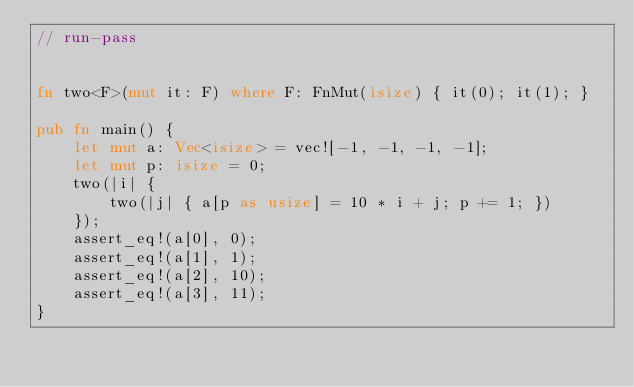<code> <loc_0><loc_0><loc_500><loc_500><_Rust_>// run-pass


fn two<F>(mut it: F) where F: FnMut(isize) { it(0); it(1); }

pub fn main() {
    let mut a: Vec<isize> = vec![-1, -1, -1, -1];
    let mut p: isize = 0;
    two(|i| {
        two(|j| { a[p as usize] = 10 * i + j; p += 1; })
    });
    assert_eq!(a[0], 0);
    assert_eq!(a[1], 1);
    assert_eq!(a[2], 10);
    assert_eq!(a[3], 11);
}
</code> 